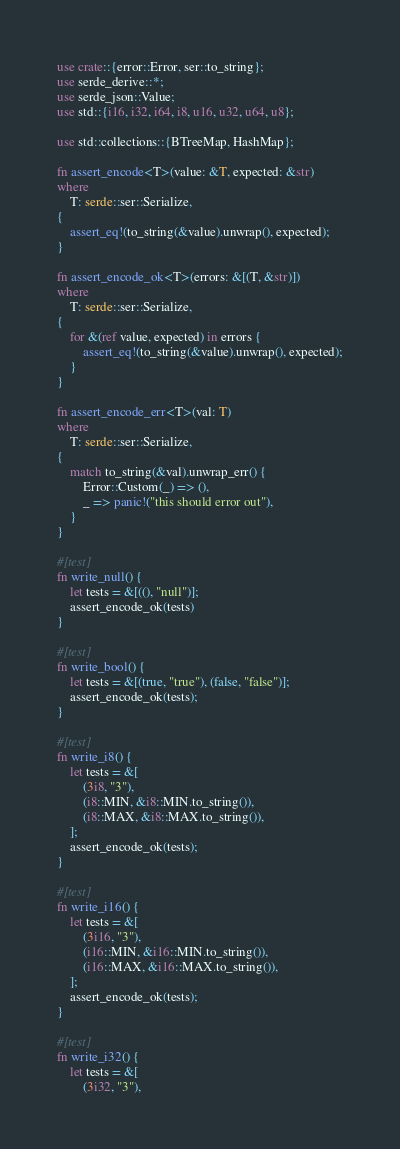<code> <loc_0><loc_0><loc_500><loc_500><_Rust_>use crate::{error::Error, ser::to_string};
use serde_derive::*;
use serde_json::Value;
use std::{i16, i32, i64, i8, u16, u32, u64, u8};

use std::collections::{BTreeMap, HashMap};

fn assert_encode<T>(value: &T, expected: &str)
where
    T: serde::ser::Serialize,
{
    assert_eq!(to_string(&value).unwrap(), expected);
}

fn assert_encode_ok<T>(errors: &[(T, &str)])
where
    T: serde::ser::Serialize,
{
    for &(ref value, expected) in errors {
        assert_eq!(to_string(&value).unwrap(), expected);
    }
}

fn assert_encode_err<T>(val: T)
where
    T: serde::ser::Serialize,
{
    match to_string(&val).unwrap_err() {
        Error::Custom(_) => (),
        _ => panic!("this should error out"),
    }
}

#[test]
fn write_null() {
    let tests = &[((), "null")];
    assert_encode_ok(tests)
}

#[test]
fn write_bool() {
    let tests = &[(true, "true"), (false, "false")];
    assert_encode_ok(tests);
}

#[test]
fn write_i8() {
    let tests = &[
        (3i8, "3"),
        (i8::MIN, &i8::MIN.to_string()),
        (i8::MAX, &i8::MAX.to_string()),
    ];
    assert_encode_ok(tests);
}

#[test]
fn write_i16() {
    let tests = &[
        (3i16, "3"),
        (i16::MIN, &i16::MIN.to_string()),
        (i16::MAX, &i16::MAX.to_string()),
    ];
    assert_encode_ok(tests);
}

#[test]
fn write_i32() {
    let tests = &[
        (3i32, "3"),</code> 